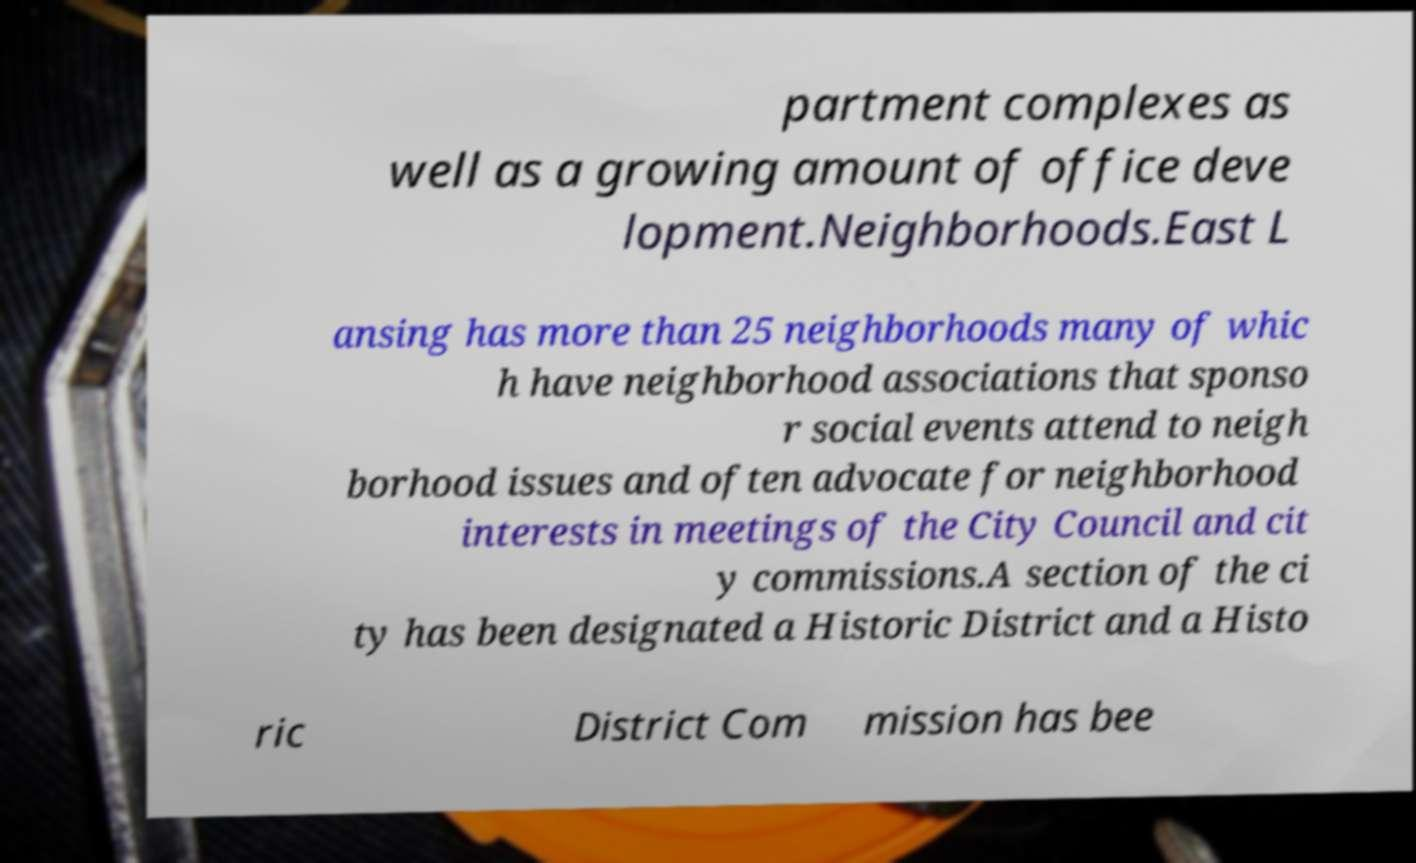I need the written content from this picture converted into text. Can you do that? partment complexes as well as a growing amount of office deve lopment.Neighborhoods.East L ansing has more than 25 neighborhoods many of whic h have neighborhood associations that sponso r social events attend to neigh borhood issues and often advocate for neighborhood interests in meetings of the City Council and cit y commissions.A section of the ci ty has been designated a Historic District and a Histo ric District Com mission has bee 